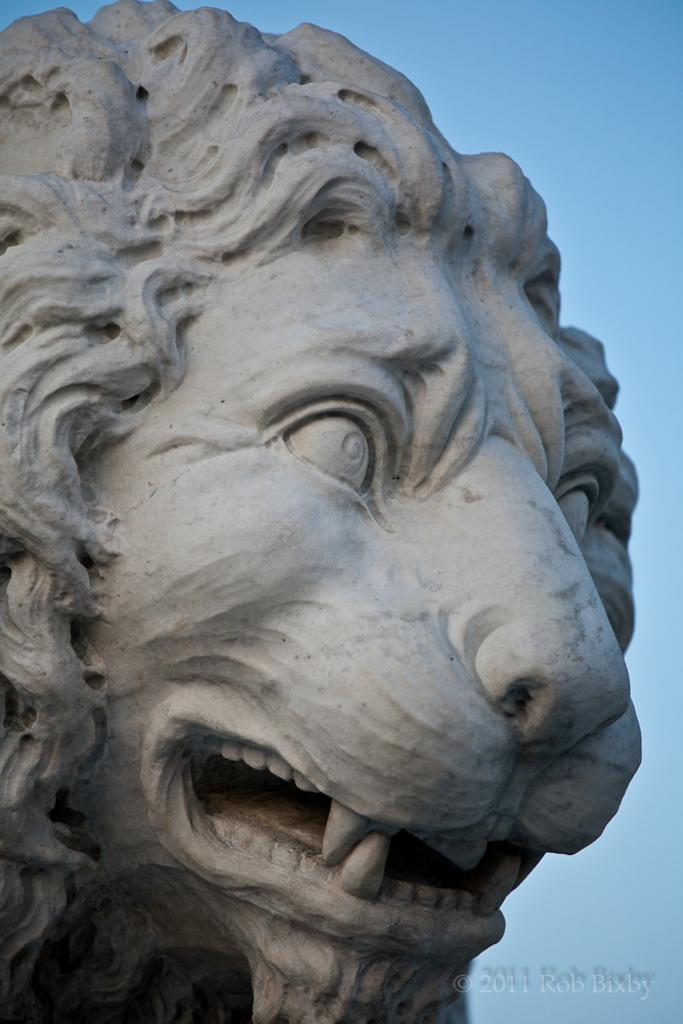What is the main subject of the image? There is a sculpture in the image. Can you describe any additional details about the sculpture? Unfortunately, the provided facts do not offer any additional details about the sculpture. Is there any text present in the image? Yes, there is text in the bottom right-hand corner of the image. How many spiders are crawling on the sculpture in the image? There are no spiders present in the image; it only features a sculpture and text. 